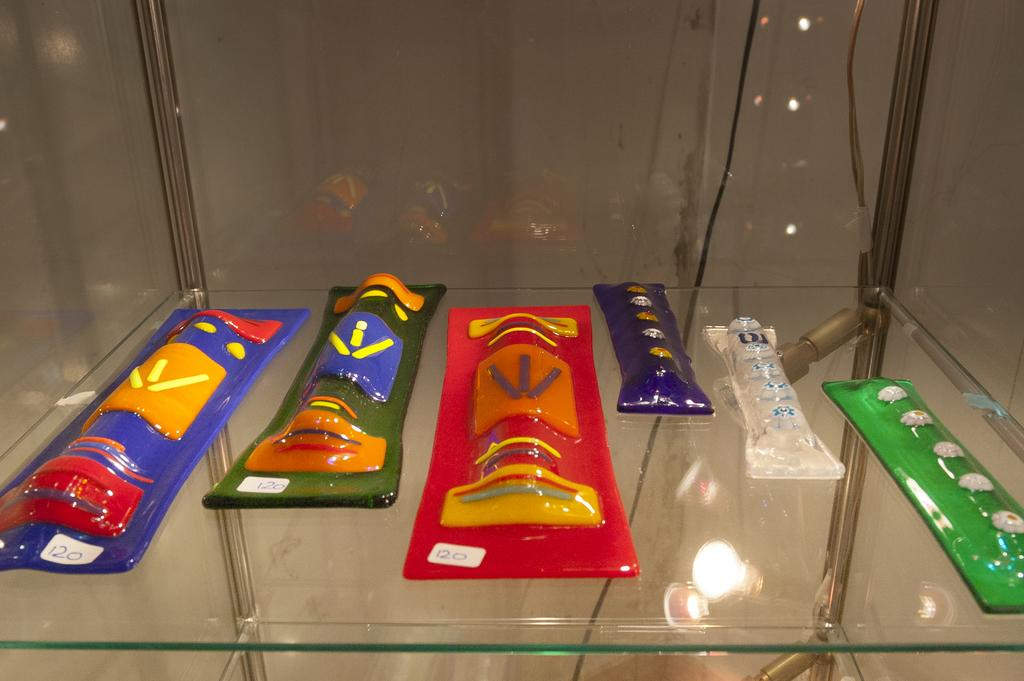What type of shelf is visible in the image? There is a glass shelf in the image. What is placed on the glass shelf? There are objects on the glass shelf. What can be seen behind the shelf in the image? There is a wall visible in the image. What else is present in the image besides the shelf and wall? There are wires in the image. Can you describe any visual effects in the image? There is a reflection of objects in the image. What type of treatment is being administered to the hole in the image? There is no hole present in the image, so no treatment is being administered. What type of desk can be seen in the image? There is no desk present in the image. 